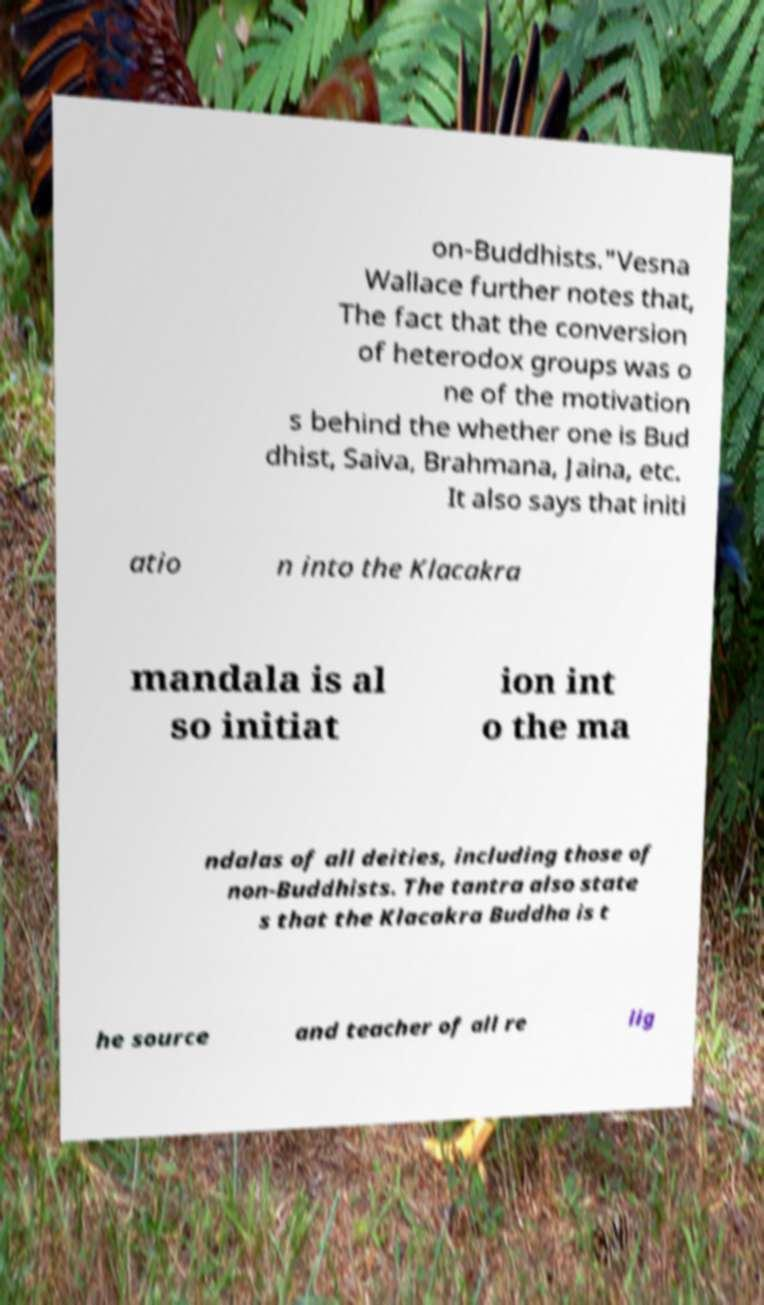Can you read and provide the text displayed in the image?This photo seems to have some interesting text. Can you extract and type it out for me? on-Buddhists."Vesna Wallace further notes that, The fact that the conversion of heterodox groups was o ne of the motivation s behind the whether one is Bud dhist, Saiva, Brahmana, Jaina, etc. It also says that initi atio n into the Klacakra mandala is al so initiat ion int o the ma ndalas of all deities, including those of non-Buddhists. The tantra also state s that the Klacakra Buddha is t he source and teacher of all re lig 